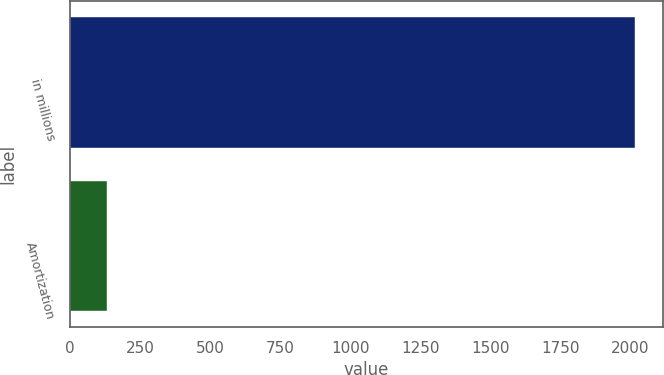Convert chart. <chart><loc_0><loc_0><loc_500><loc_500><bar_chart><fcel>in millions<fcel>Amortization<nl><fcel>2015<fcel>132<nl></chart> 